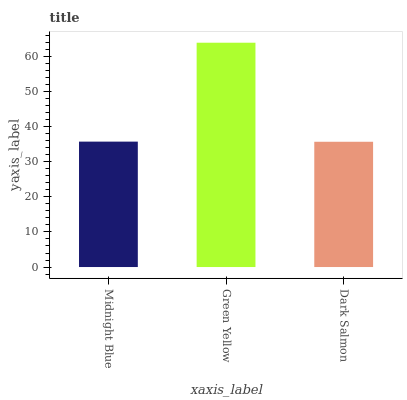Is Dark Salmon the minimum?
Answer yes or no. Yes. Is Green Yellow the maximum?
Answer yes or no. Yes. Is Green Yellow the minimum?
Answer yes or no. No. Is Dark Salmon the maximum?
Answer yes or no. No. Is Green Yellow greater than Dark Salmon?
Answer yes or no. Yes. Is Dark Salmon less than Green Yellow?
Answer yes or no. Yes. Is Dark Salmon greater than Green Yellow?
Answer yes or no. No. Is Green Yellow less than Dark Salmon?
Answer yes or no. No. Is Midnight Blue the high median?
Answer yes or no. Yes. Is Midnight Blue the low median?
Answer yes or no. Yes. Is Green Yellow the high median?
Answer yes or no. No. Is Green Yellow the low median?
Answer yes or no. No. 